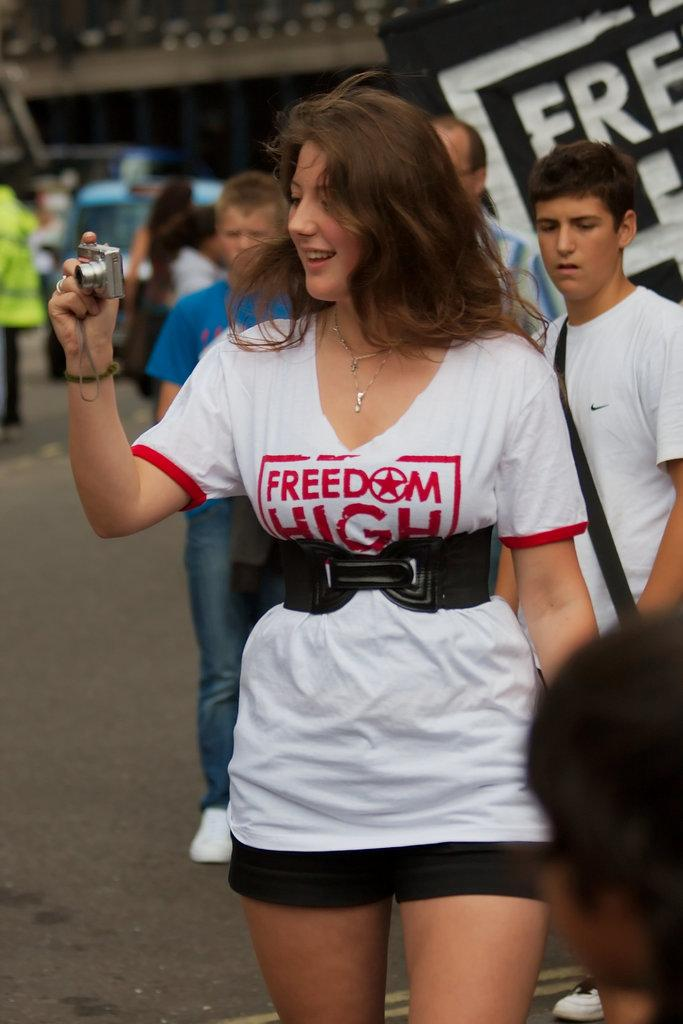Provide a one-sentence caption for the provided image. An attractive young lady wearing a white T-shirt with the slogan Freedom High takes a photo of those around her with a camera. 